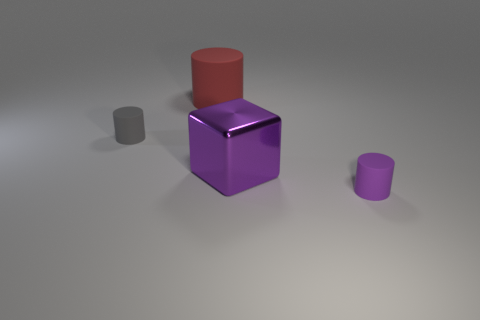Add 3 big yellow shiny cylinders. How many objects exist? 7 Subtract all cubes. How many objects are left? 3 Add 2 red cylinders. How many red cylinders are left? 3 Add 2 big red objects. How many big red objects exist? 3 Subtract 0 gray blocks. How many objects are left? 4 Subtract all small brown shiny spheres. Subtract all big things. How many objects are left? 2 